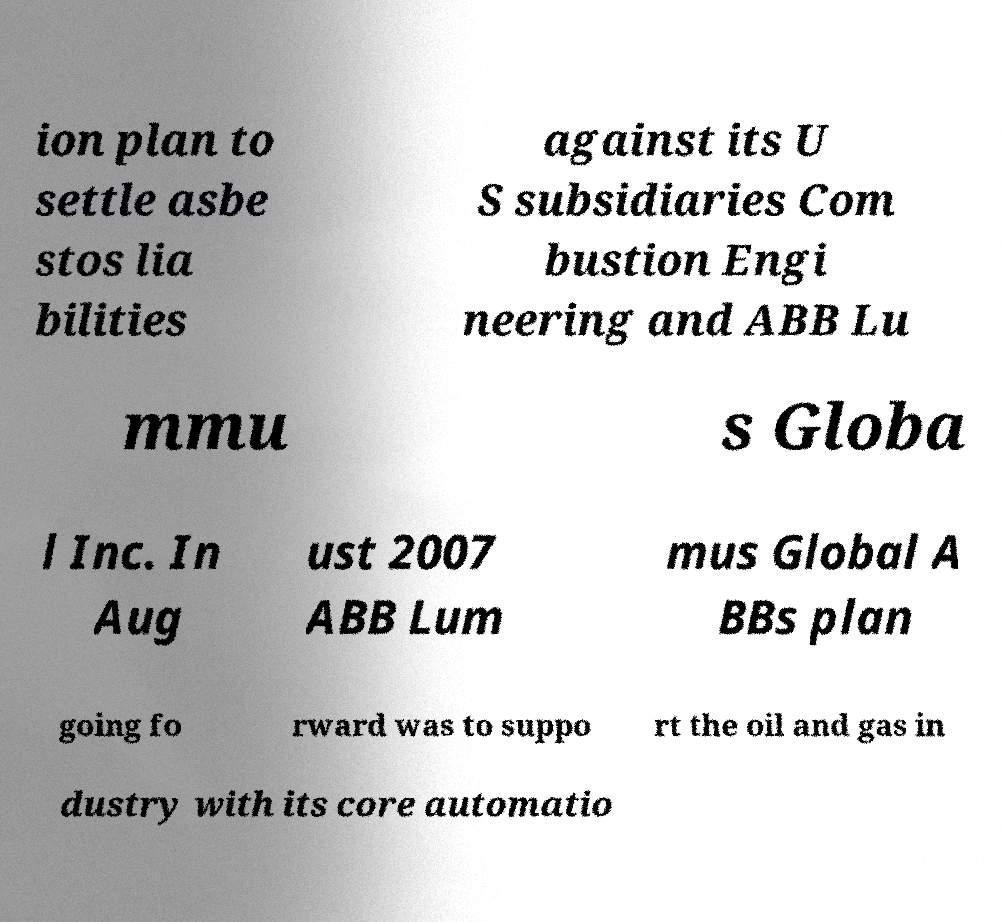What messages or text are displayed in this image? I need them in a readable, typed format. ion plan to settle asbe stos lia bilities against its U S subsidiaries Com bustion Engi neering and ABB Lu mmu s Globa l Inc. In Aug ust 2007 ABB Lum mus Global A BBs plan going fo rward was to suppo rt the oil and gas in dustry with its core automatio 